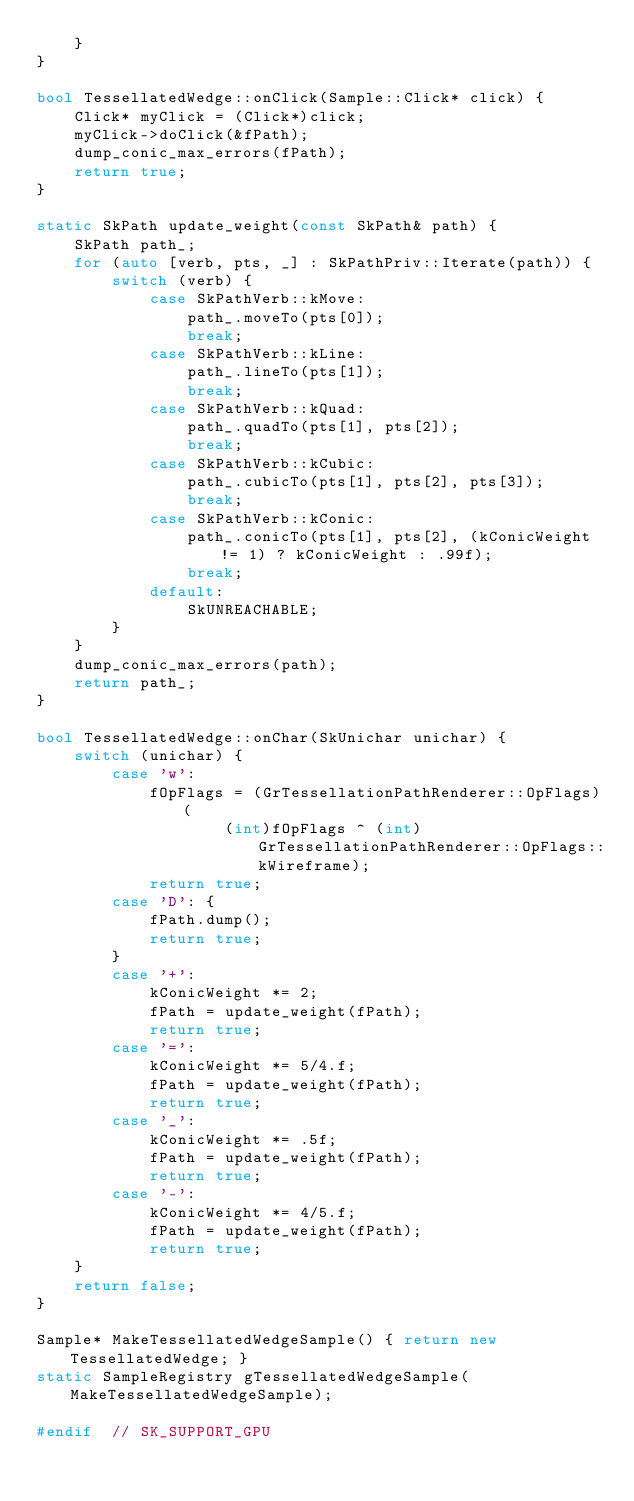<code> <loc_0><loc_0><loc_500><loc_500><_C++_>    }
}

bool TessellatedWedge::onClick(Sample::Click* click) {
    Click* myClick = (Click*)click;
    myClick->doClick(&fPath);
    dump_conic_max_errors(fPath);
    return true;
}

static SkPath update_weight(const SkPath& path) {
    SkPath path_;
    for (auto [verb, pts, _] : SkPathPriv::Iterate(path)) {
        switch (verb) {
            case SkPathVerb::kMove:
                path_.moveTo(pts[0]);
                break;
            case SkPathVerb::kLine:
                path_.lineTo(pts[1]);
                break;
            case SkPathVerb::kQuad:
                path_.quadTo(pts[1], pts[2]);
                break;
            case SkPathVerb::kCubic:
                path_.cubicTo(pts[1], pts[2], pts[3]);
                break;
            case SkPathVerb::kConic:
                path_.conicTo(pts[1], pts[2], (kConicWeight != 1) ? kConicWeight : .99f);
                break;
            default:
                SkUNREACHABLE;
        }
    }
    dump_conic_max_errors(path);
    return path_;
}

bool TessellatedWedge::onChar(SkUnichar unichar) {
    switch (unichar) {
        case 'w':
            fOpFlags = (GrTessellationPathRenderer::OpFlags)(
                    (int)fOpFlags ^ (int)GrTessellationPathRenderer::OpFlags::kWireframe);
            return true;
        case 'D': {
            fPath.dump();
            return true;
        }
        case '+':
            kConicWeight *= 2;
            fPath = update_weight(fPath);
            return true;
        case '=':
            kConicWeight *= 5/4.f;
            fPath = update_weight(fPath);
            return true;
        case '_':
            kConicWeight *= .5f;
            fPath = update_weight(fPath);
            return true;
        case '-':
            kConicWeight *= 4/5.f;
            fPath = update_weight(fPath);
            return true;
    }
    return false;
}

Sample* MakeTessellatedWedgeSample() { return new TessellatedWedge; }
static SampleRegistry gTessellatedWedgeSample(MakeTessellatedWedgeSample);

#endif  // SK_SUPPORT_GPU
</code> 